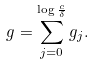Convert formula to latex. <formula><loc_0><loc_0><loc_500><loc_500>g = \sum _ { j = 0 } ^ { \log \frac { c } { \delta } } g _ { j } .</formula> 